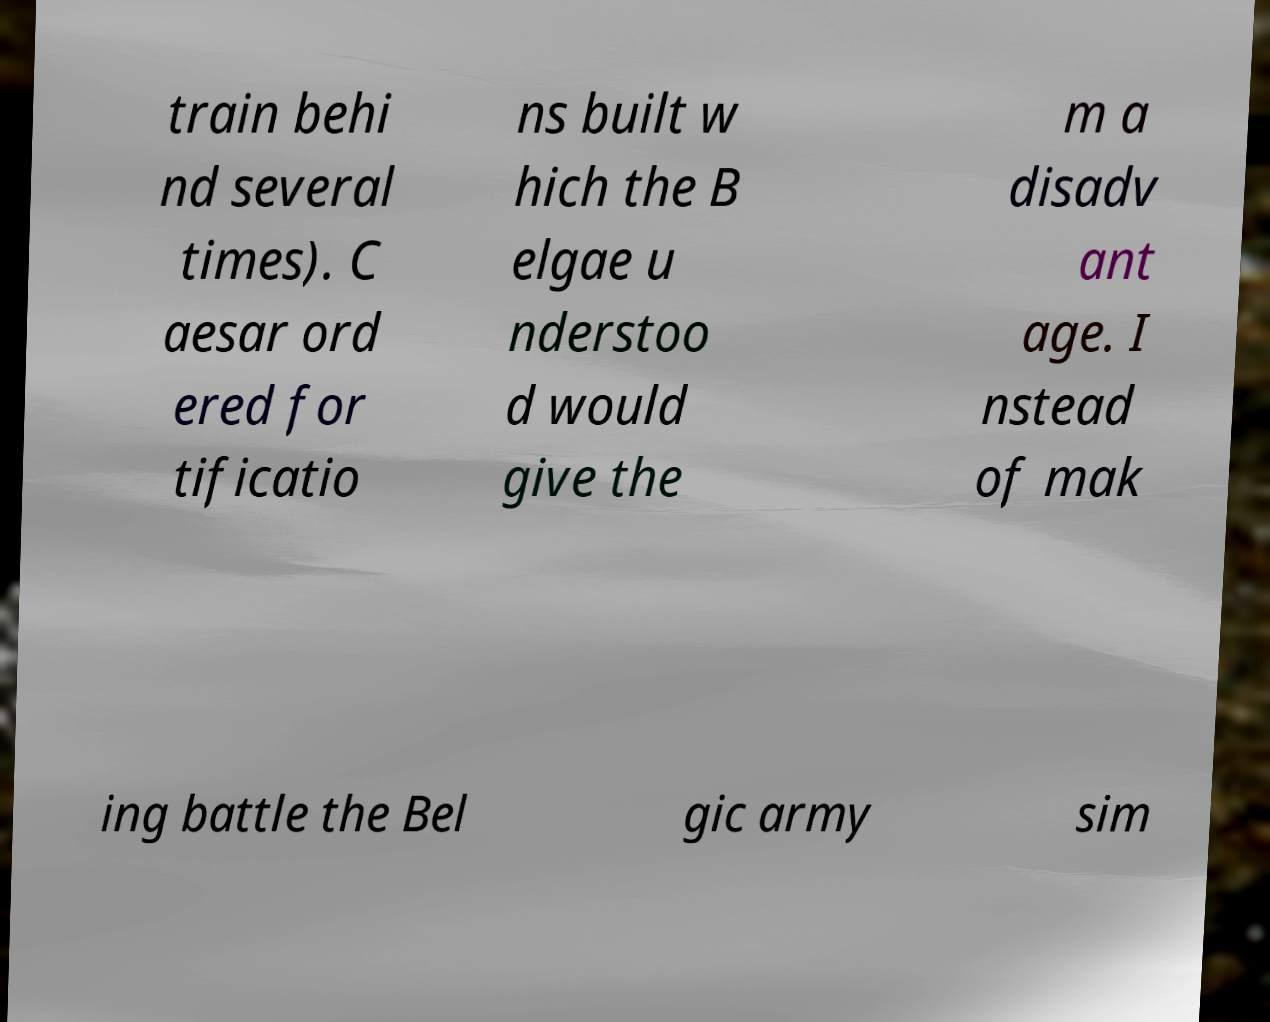What messages or text are displayed in this image? I need them in a readable, typed format. train behi nd several times). C aesar ord ered for tificatio ns built w hich the B elgae u nderstoo d would give the m a disadv ant age. I nstead of mak ing battle the Bel gic army sim 